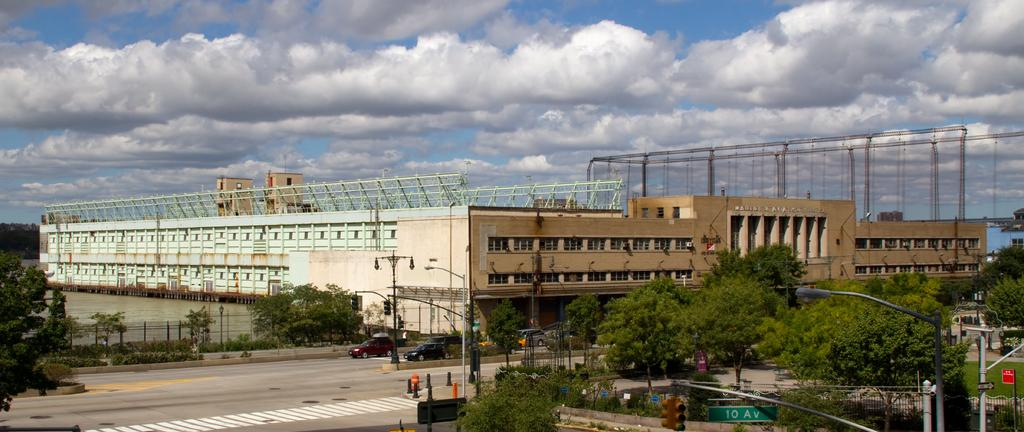What is the main feature of the image? There is a road in the image. What else can be seen on the road? There are vehicles in the image. What type of natural elements are present in the image? There are trees in the image. What type of artificial elements are present in the image? There are street lights in the image. What type of landscape feature is present in the image? There is a water surface in the image. What type of man-made structure is present in the image? There is a huge architecture in the image. What type of game is being played by the parent in the image? There is no game or parent present in the image; it features a road, vehicles, trees, street lights, water surface, and a huge architecture. 